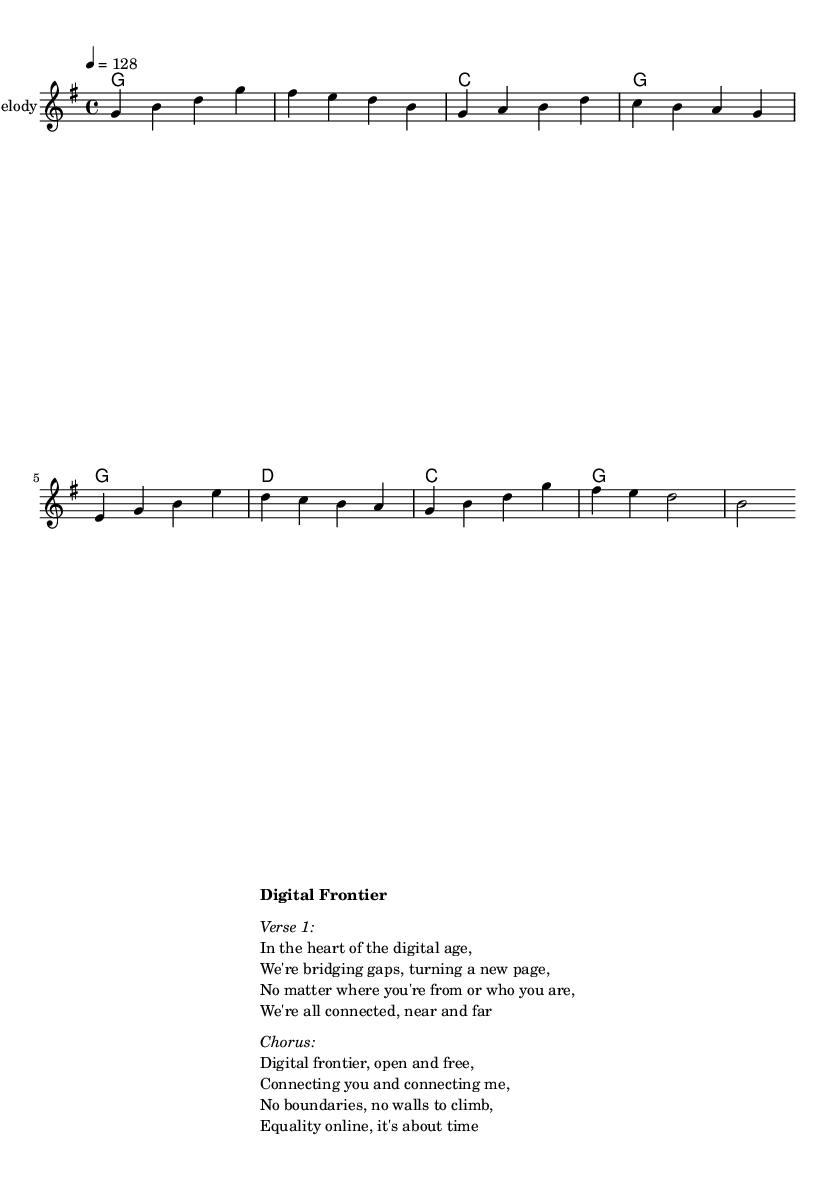What is the key signature of this music? The key signature is G major, which has one sharp (F#). This can be determined by looking at the key signature at the beginning of the staff.
Answer: G major What is the time signature of this music? The time signature is 4/4, which means there are four beats in a measure and the quarter note gets one beat. This is indicated in the music notation following the clef.
Answer: 4/4 What is the tempo marking of this piece? The tempo marking indicates a speed of 128 beats per minute, specified as "4 = 128" in the global section of the code. This tells performers how fast to play.
Answer: 128 What is the title of the song? The title is "Digital Frontier," which is indicated in bold type in the markup section, suggesting it is the main theme of the song.
Answer: Digital Frontier How many measures does the melody have? The melody consists of 8 measures, as counted by the phrases separated by the bar lines in the provided melody data. Each grouping of note sequences represents one measure.
Answer: 8 What is the harmonic structure of the music? The harmonic structure consists of chords played in the following sequence: G, C, G, G, D, C, G. The chord symbols are shown in the harmonies section.
Answer: G C G G D C G What is the main theme of the chorus? The main theme of the chorus focuses on digital equality and connectivity, emphasizing that "No boundaries, no walls to climb" and promoting an open digital space. This is evident from the lyrics provided in the markup section.
Answer: Equality online 